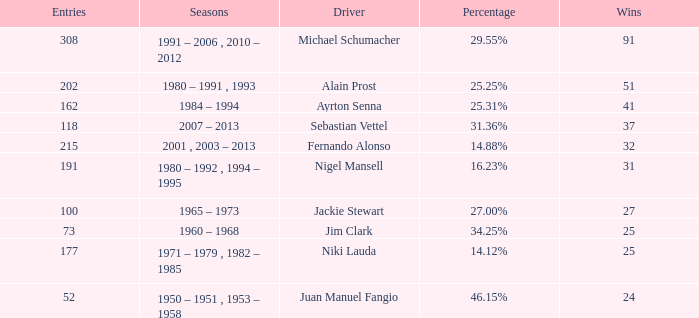Which season did jackie stewart enter with entries less than 215? 1965 – 1973. 